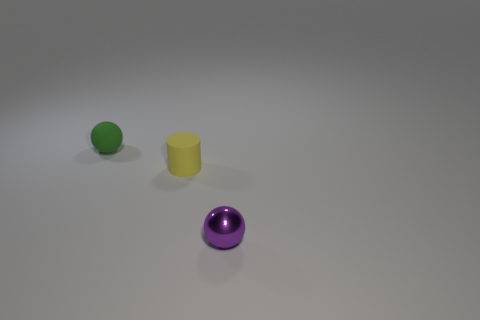There is a small ball that is on the left side of the tiny purple metal sphere; does it have the same color as the cylinder?
Your response must be concise. No. Is the number of tiny matte objects that are left of the rubber ball less than the number of cyan objects?
Make the answer very short. No. What color is the other tiny thing that is made of the same material as the yellow object?
Provide a short and direct response. Green. What size is the matte object in front of the matte ball?
Offer a very short reply. Small. Is the material of the tiny cylinder the same as the green thing?
Your answer should be compact. Yes. There is a rubber object on the right side of the tiny ball that is behind the rubber cylinder; is there a purple shiny thing behind it?
Your answer should be compact. No. What is the color of the metallic object?
Your answer should be compact. Purple. What is the color of the other metal ball that is the same size as the green sphere?
Your response must be concise. Purple. Do the tiny rubber thing on the right side of the green rubber thing and the purple metal object have the same shape?
Give a very brief answer. No. What is the color of the small rubber thing behind the matte thing on the right side of the tiny sphere on the left side of the purple sphere?
Keep it short and to the point. Green. 